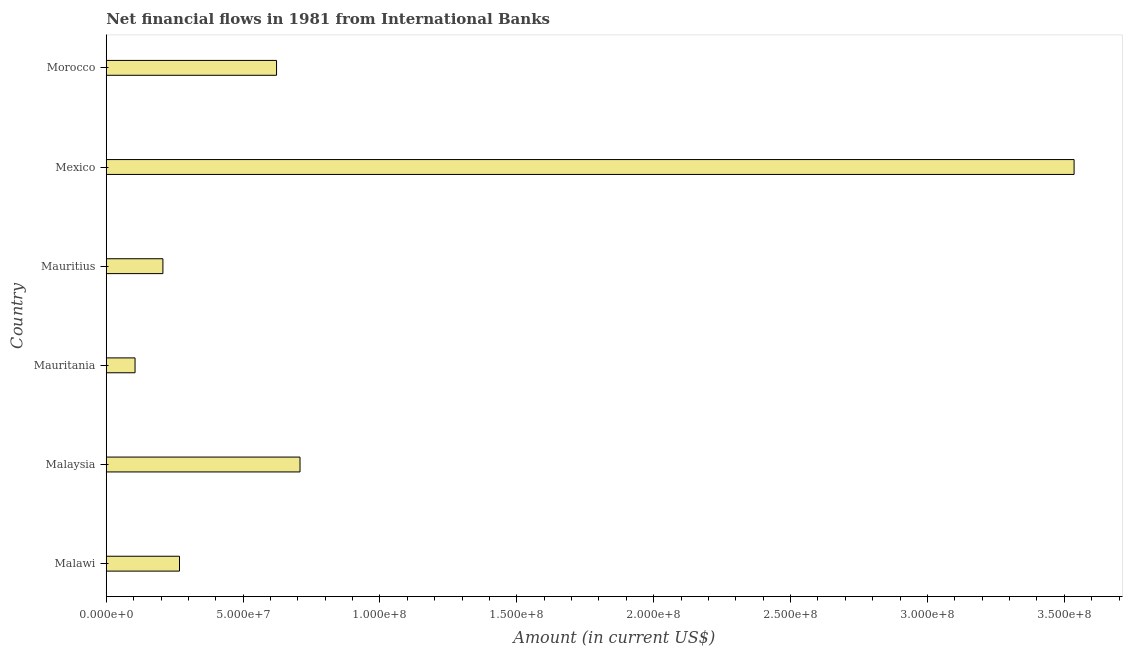Does the graph contain grids?
Your response must be concise. No. What is the title of the graph?
Your answer should be compact. Net financial flows in 1981 from International Banks. What is the label or title of the Y-axis?
Your answer should be very brief. Country. What is the net financial flows from ibrd in Morocco?
Keep it short and to the point. 6.22e+07. Across all countries, what is the maximum net financial flows from ibrd?
Give a very brief answer. 3.54e+08. Across all countries, what is the minimum net financial flows from ibrd?
Make the answer very short. 1.05e+07. In which country was the net financial flows from ibrd minimum?
Offer a very short reply. Mauritania. What is the sum of the net financial flows from ibrd?
Provide a short and direct response. 5.45e+08. What is the difference between the net financial flows from ibrd in Malaysia and Mexico?
Give a very brief answer. -2.83e+08. What is the average net financial flows from ibrd per country?
Provide a short and direct response. 9.08e+07. What is the median net financial flows from ibrd?
Provide a succinct answer. 4.45e+07. In how many countries, is the net financial flows from ibrd greater than 200000000 US$?
Keep it short and to the point. 1. What is the ratio of the net financial flows from ibrd in Malawi to that in Mauritania?
Keep it short and to the point. 2.54. Is the difference between the net financial flows from ibrd in Mauritania and Mauritius greater than the difference between any two countries?
Provide a short and direct response. No. What is the difference between the highest and the second highest net financial flows from ibrd?
Provide a short and direct response. 2.83e+08. Is the sum of the net financial flows from ibrd in Mauritania and Mexico greater than the maximum net financial flows from ibrd across all countries?
Offer a terse response. Yes. What is the difference between the highest and the lowest net financial flows from ibrd?
Provide a short and direct response. 3.43e+08. In how many countries, is the net financial flows from ibrd greater than the average net financial flows from ibrd taken over all countries?
Offer a very short reply. 1. How many bars are there?
Make the answer very short. 6. Are all the bars in the graph horizontal?
Your answer should be very brief. Yes. Are the values on the major ticks of X-axis written in scientific E-notation?
Keep it short and to the point. Yes. What is the Amount (in current US$) of Malawi?
Ensure brevity in your answer.  2.68e+07. What is the Amount (in current US$) of Malaysia?
Provide a succinct answer. 7.08e+07. What is the Amount (in current US$) of Mauritania?
Provide a succinct answer. 1.05e+07. What is the Amount (in current US$) in Mauritius?
Your answer should be very brief. 2.07e+07. What is the Amount (in current US$) of Mexico?
Give a very brief answer. 3.54e+08. What is the Amount (in current US$) in Morocco?
Your answer should be very brief. 6.22e+07. What is the difference between the Amount (in current US$) in Malawi and Malaysia?
Your answer should be very brief. -4.40e+07. What is the difference between the Amount (in current US$) in Malawi and Mauritania?
Make the answer very short. 1.62e+07. What is the difference between the Amount (in current US$) in Malawi and Mauritius?
Ensure brevity in your answer.  6.06e+06. What is the difference between the Amount (in current US$) in Malawi and Mexico?
Your response must be concise. -3.27e+08. What is the difference between the Amount (in current US$) in Malawi and Morocco?
Ensure brevity in your answer.  -3.55e+07. What is the difference between the Amount (in current US$) in Malaysia and Mauritania?
Offer a terse response. 6.03e+07. What is the difference between the Amount (in current US$) in Malaysia and Mauritius?
Keep it short and to the point. 5.01e+07. What is the difference between the Amount (in current US$) in Malaysia and Mexico?
Offer a very short reply. -2.83e+08. What is the difference between the Amount (in current US$) in Malaysia and Morocco?
Provide a succinct answer. 8.57e+06. What is the difference between the Amount (in current US$) in Mauritania and Mauritius?
Offer a very short reply. -1.02e+07. What is the difference between the Amount (in current US$) in Mauritania and Mexico?
Offer a very short reply. -3.43e+08. What is the difference between the Amount (in current US$) in Mauritania and Morocco?
Provide a succinct answer. -5.17e+07. What is the difference between the Amount (in current US$) in Mauritius and Mexico?
Provide a short and direct response. -3.33e+08. What is the difference between the Amount (in current US$) in Mauritius and Morocco?
Give a very brief answer. -4.15e+07. What is the difference between the Amount (in current US$) in Mexico and Morocco?
Ensure brevity in your answer.  2.91e+08. What is the ratio of the Amount (in current US$) in Malawi to that in Malaysia?
Ensure brevity in your answer.  0.38. What is the ratio of the Amount (in current US$) in Malawi to that in Mauritania?
Offer a very short reply. 2.54. What is the ratio of the Amount (in current US$) in Malawi to that in Mauritius?
Keep it short and to the point. 1.29. What is the ratio of the Amount (in current US$) in Malawi to that in Mexico?
Offer a terse response. 0.08. What is the ratio of the Amount (in current US$) in Malawi to that in Morocco?
Your response must be concise. 0.43. What is the ratio of the Amount (in current US$) in Malaysia to that in Mauritania?
Ensure brevity in your answer.  6.73. What is the ratio of the Amount (in current US$) in Malaysia to that in Mauritius?
Your answer should be compact. 3.42. What is the ratio of the Amount (in current US$) in Malaysia to that in Morocco?
Offer a terse response. 1.14. What is the ratio of the Amount (in current US$) in Mauritania to that in Mauritius?
Offer a very short reply. 0.51. What is the ratio of the Amount (in current US$) in Mauritania to that in Morocco?
Ensure brevity in your answer.  0.17. What is the ratio of the Amount (in current US$) in Mauritius to that in Mexico?
Offer a very short reply. 0.06. What is the ratio of the Amount (in current US$) in Mauritius to that in Morocco?
Your answer should be very brief. 0.33. What is the ratio of the Amount (in current US$) in Mexico to that in Morocco?
Provide a succinct answer. 5.68. 